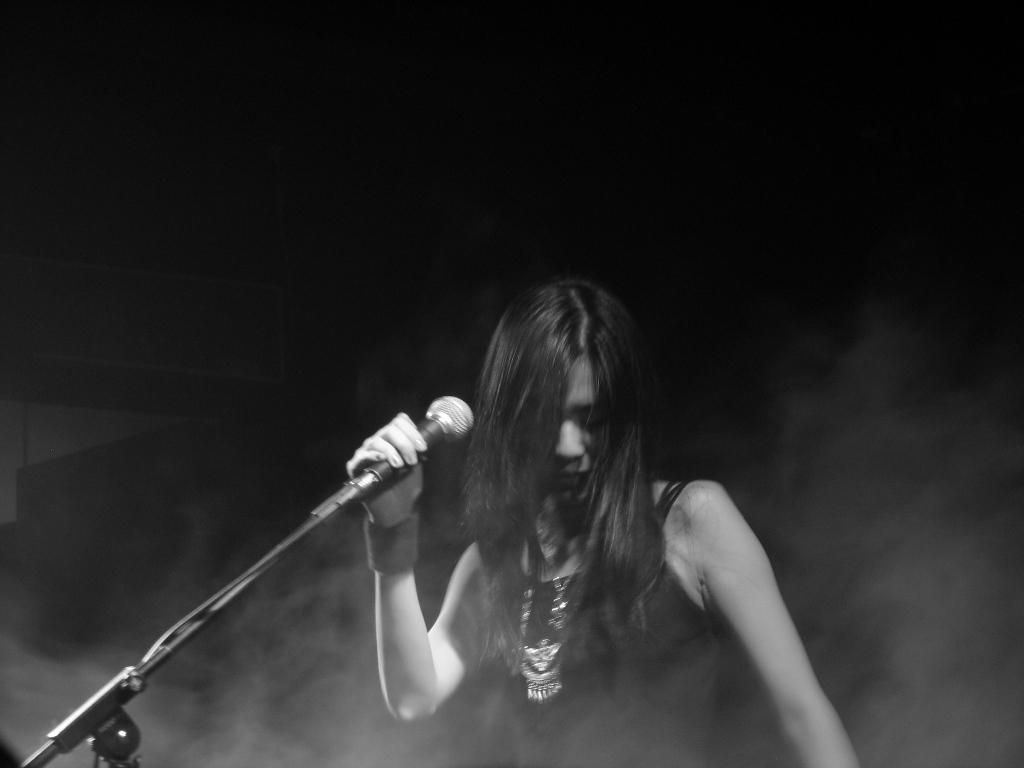Who is the main subject in the image? There is a woman in the image. What is the woman doing in the image? The woman is standing and holding a microphone in her hand. What can be observed about the background of the image? The background of the image is dark. What type of net is being used by the woman in the image? There is no net present in the image; the woman is holding a microphone. How many tickets can be seen in the woman's hand in the image? There are no tickets visible in the image; the woman is holding a microphone. 